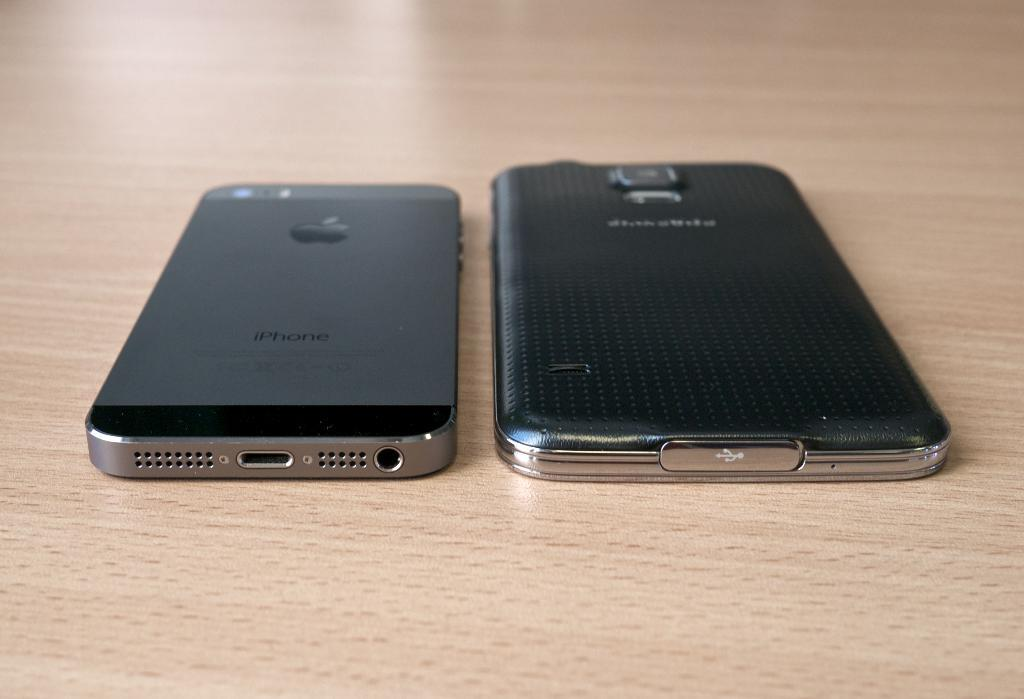<image>
Relay a brief, clear account of the picture shown. Two smart phones on a table, one of which has iphone on the back. 